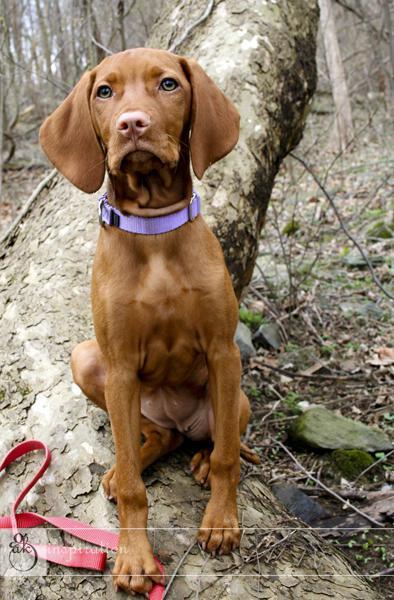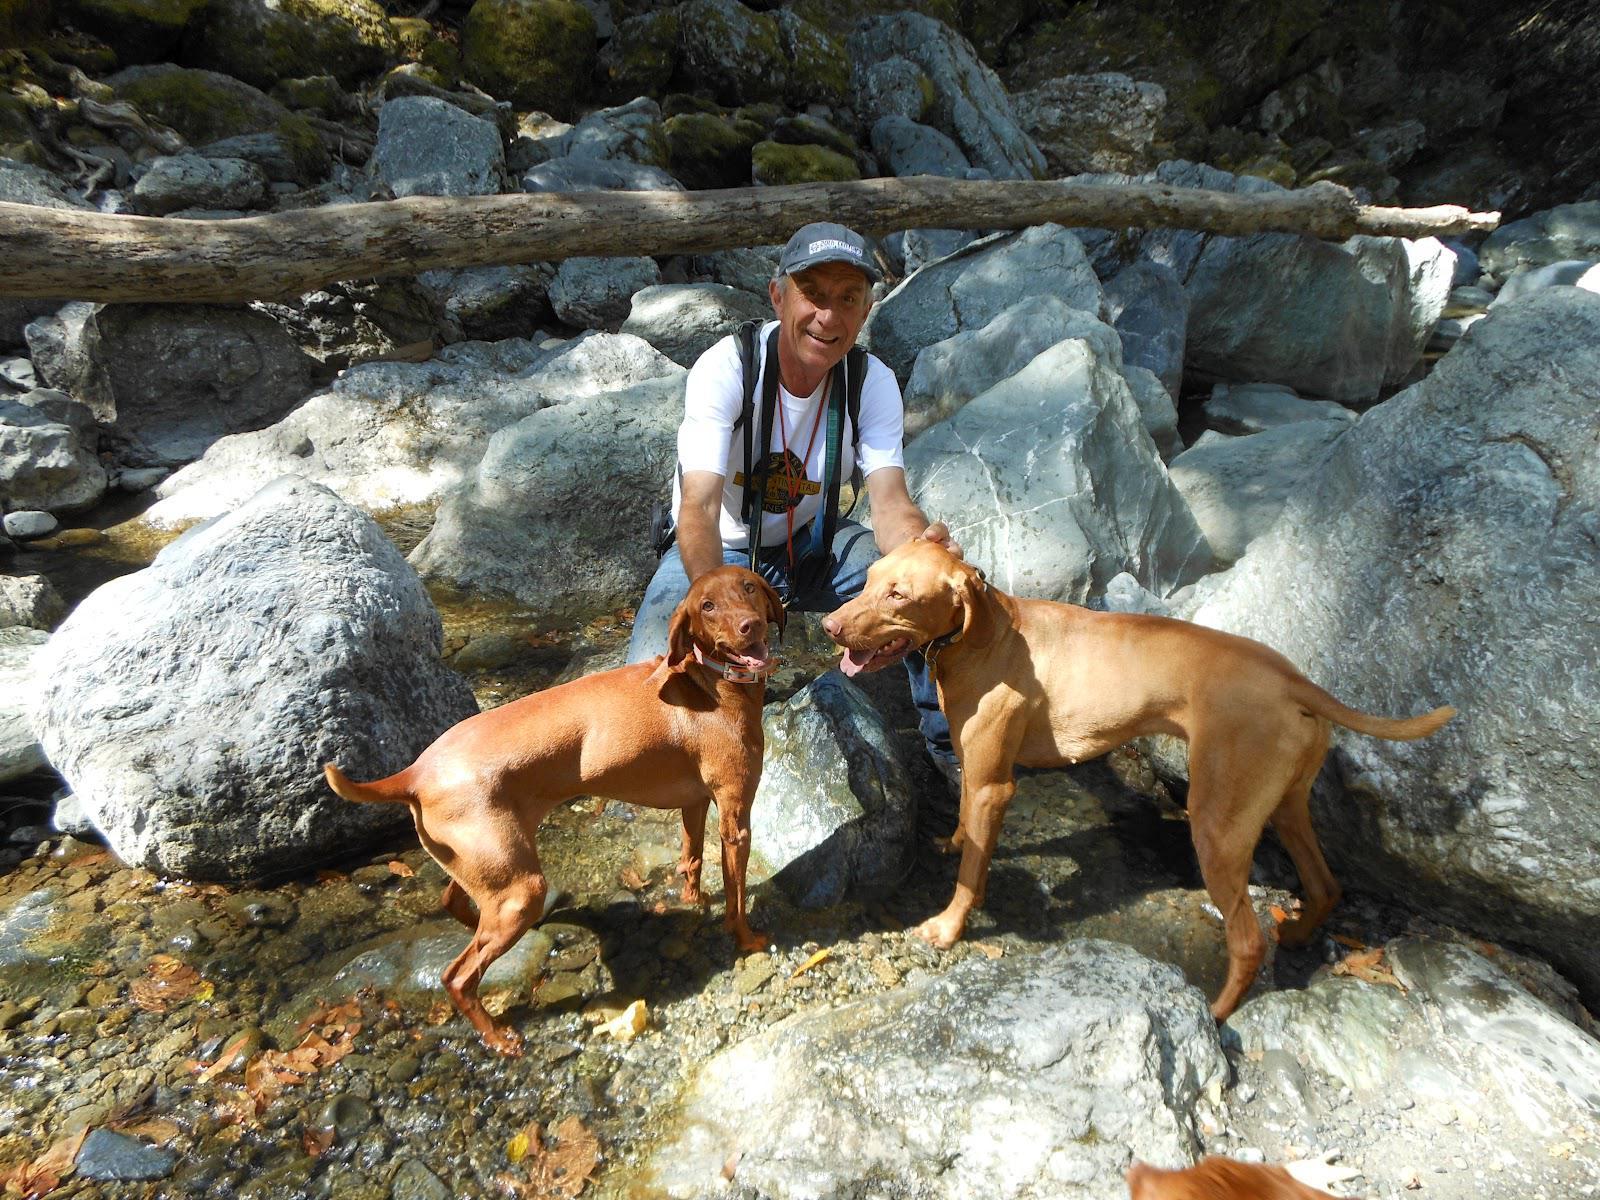The first image is the image on the left, the second image is the image on the right. Assess this claim about the two images: "In at least one image there are two hunting dogs with collars on.". Correct or not? Answer yes or no. Yes. The first image is the image on the left, the second image is the image on the right. Examine the images to the left and right. Is the description "In the right image, red-orange dogs are on each side of a man with a strap on his front." accurate? Answer yes or no. Yes. 